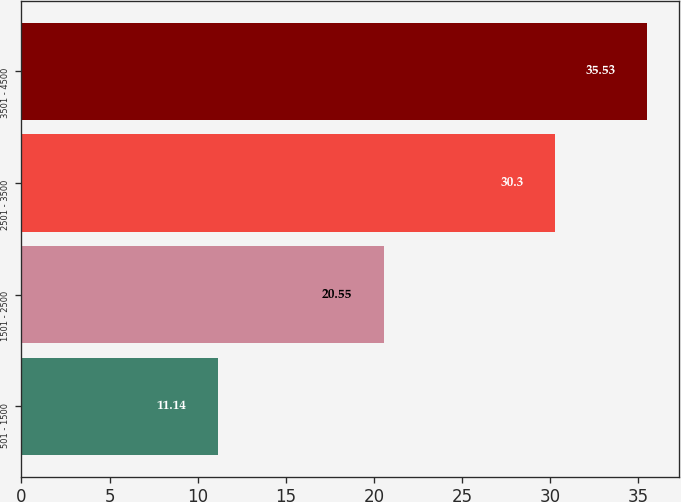Convert chart to OTSL. <chart><loc_0><loc_0><loc_500><loc_500><bar_chart><fcel>501 - 1500<fcel>1501 - 2500<fcel>2501 - 3500<fcel>3501 - 4500<nl><fcel>11.14<fcel>20.55<fcel>30.3<fcel>35.53<nl></chart> 